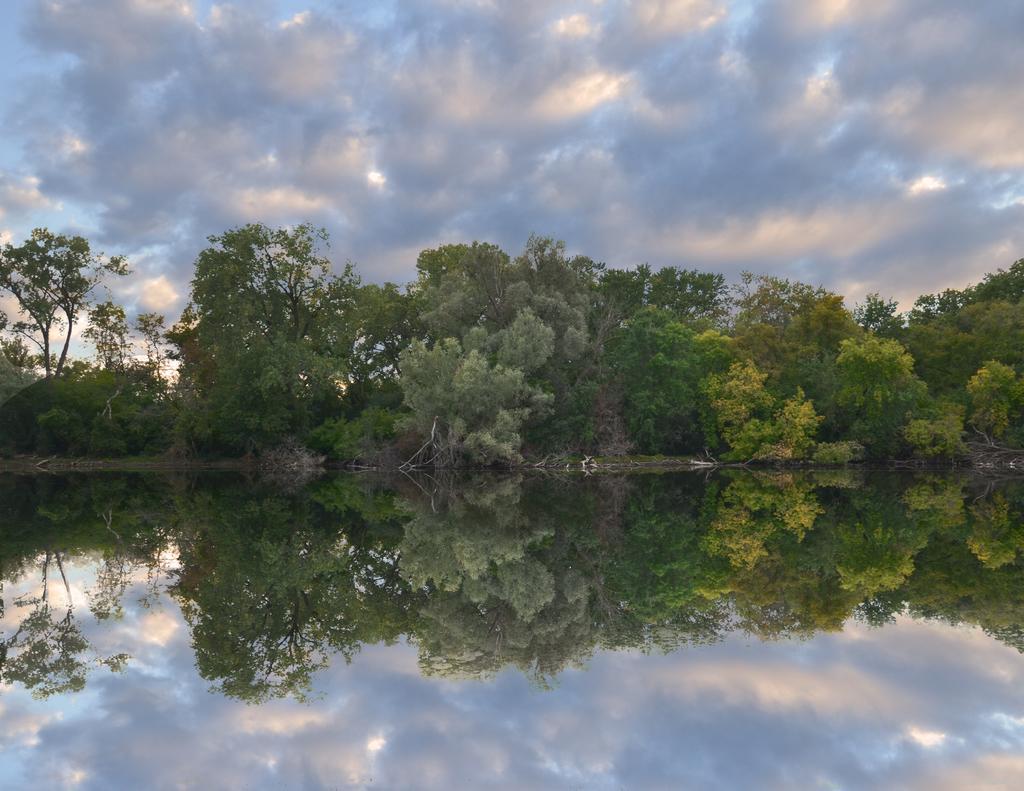Describe this image in one or two sentences. In this image there is a big lake beside that there are so many trees and clouds in the sky, also there is a reflection of trees and clouds in the water. 